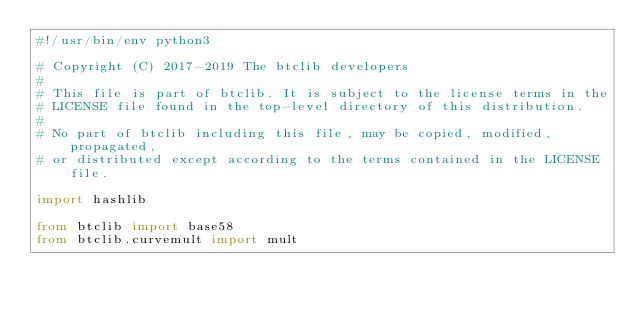Convert code to text. <code><loc_0><loc_0><loc_500><loc_500><_Python_>#!/usr/bin/env python3

# Copyright (C) 2017-2019 The btclib developers
#
# This file is part of btclib. It is subject to the license terms in the
# LICENSE file found in the top-level directory of this distribution.
#
# No part of btclib including this file, may be copied, modified, propagated,
# or distributed except according to the terms contained in the LICENSE file.

import hashlib

from btclib import base58
from btclib.curvemult import mult
</code> 